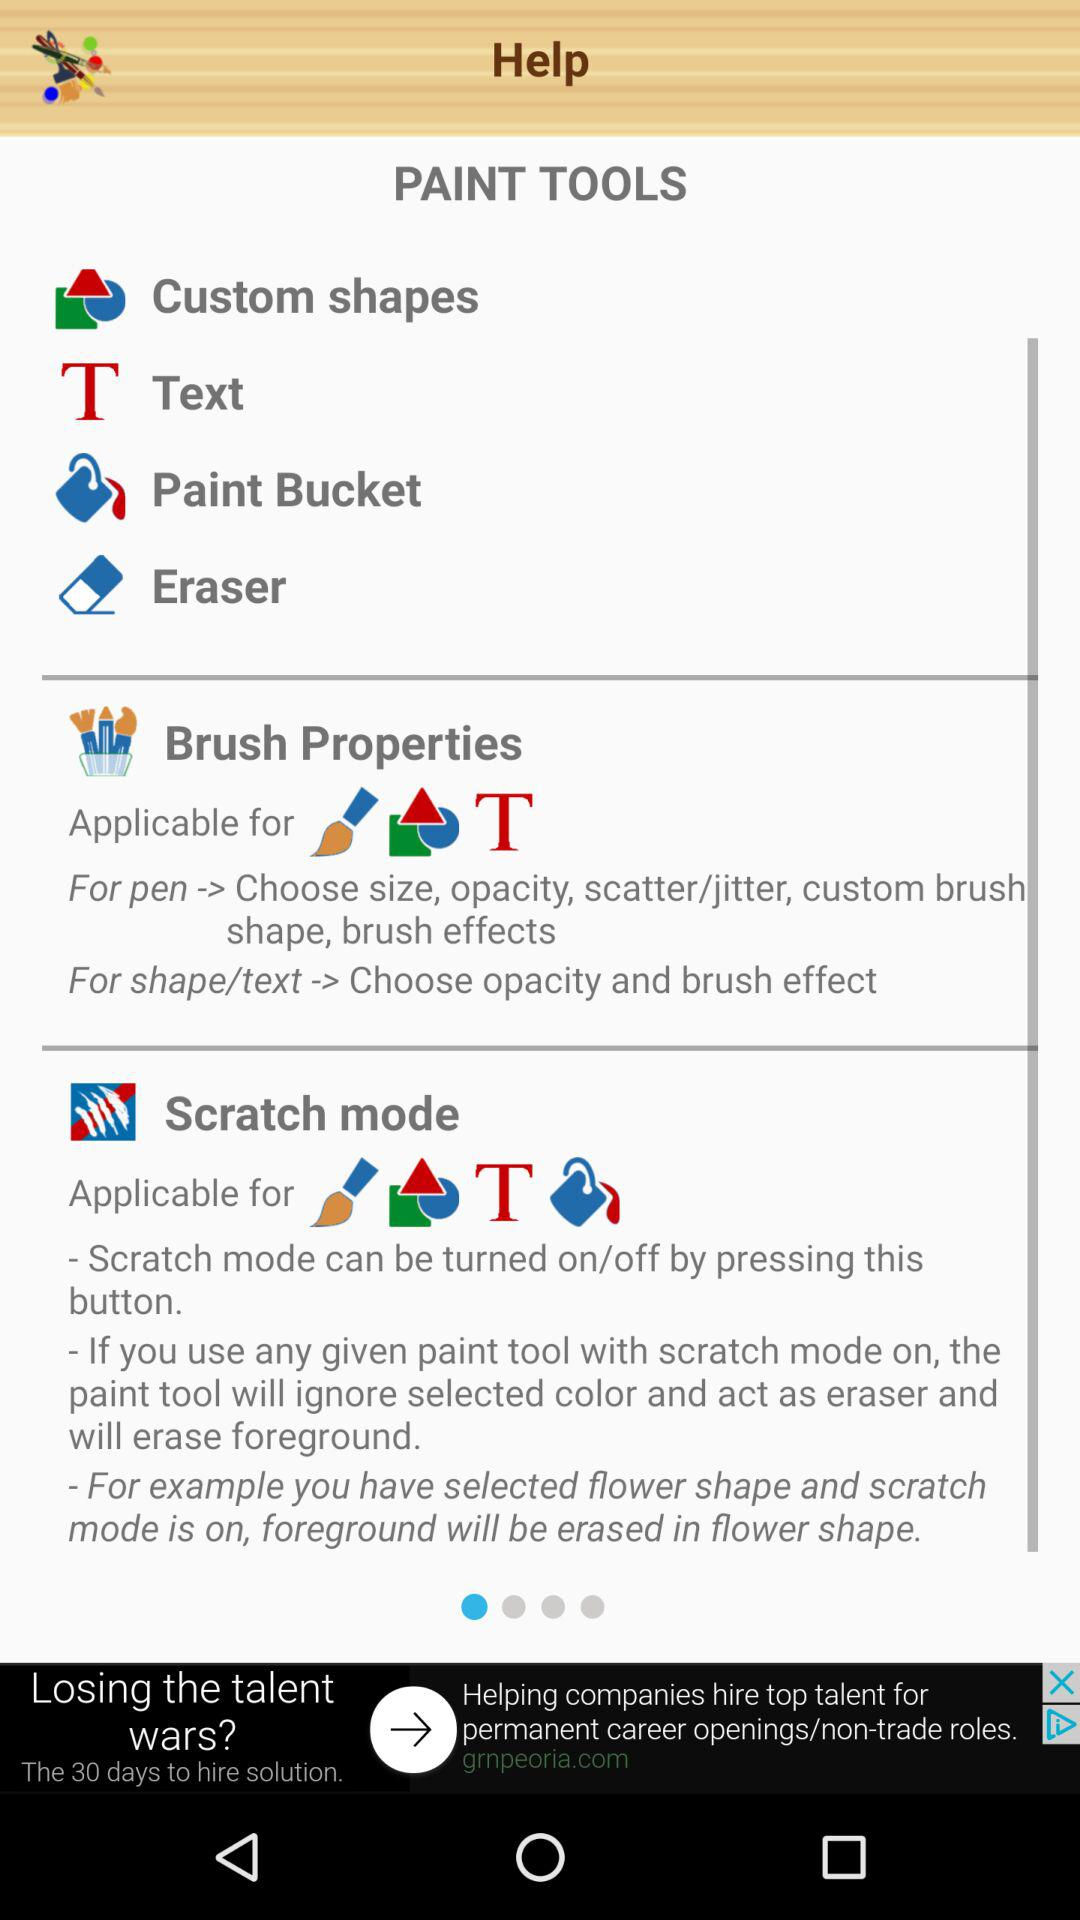What are the paint tools available? The available paint tools are: "Custom shapes", "Text", "Paint Bucket", and "Eraser". 